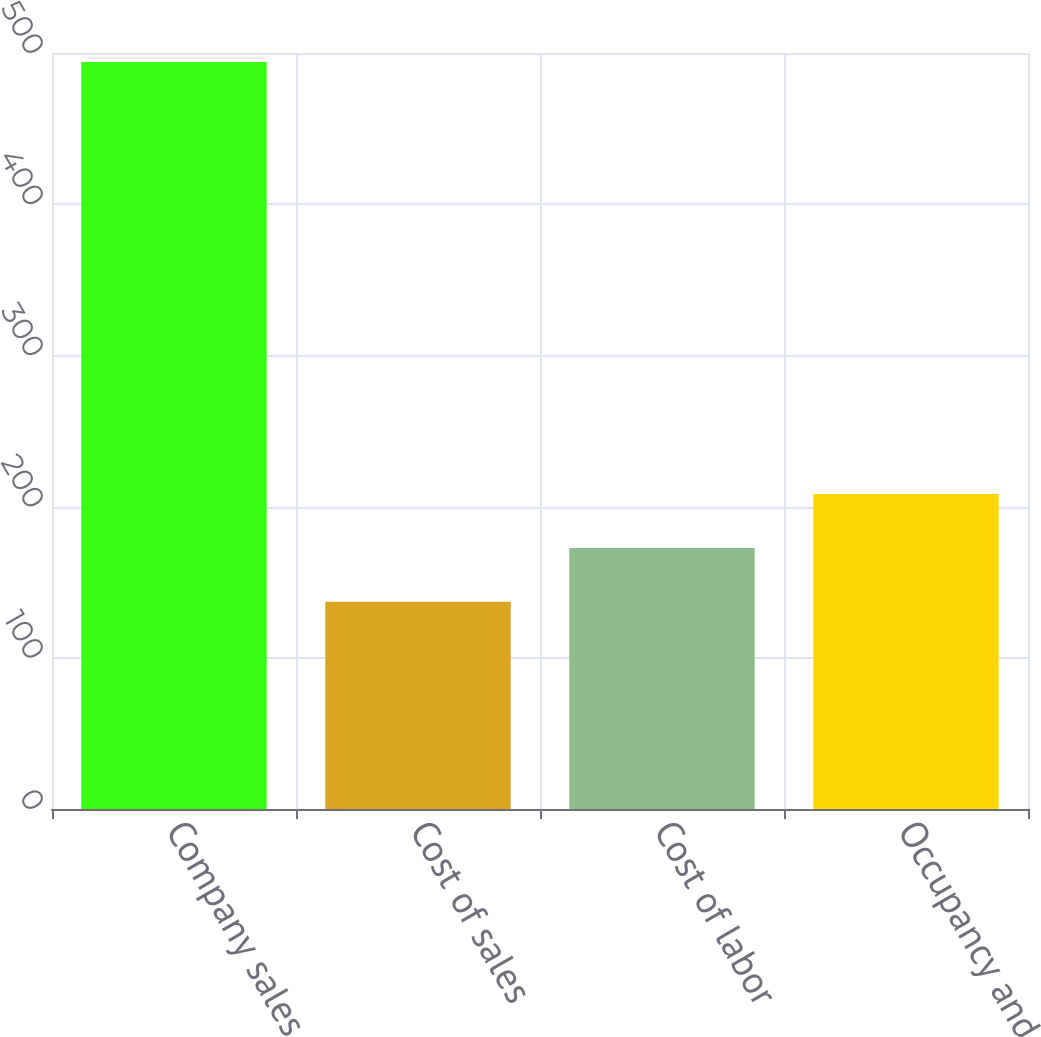<chart> <loc_0><loc_0><loc_500><loc_500><bar_chart><fcel>Company sales<fcel>Cost of sales<fcel>Cost of labor<fcel>Occupancy and other<nl><fcel>494<fcel>137<fcel>172.7<fcel>208.4<nl></chart> 